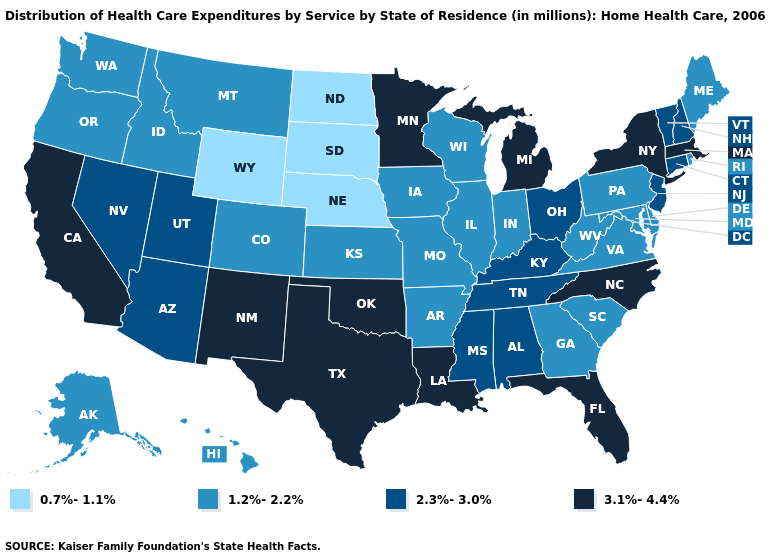Which states have the lowest value in the USA?
Concise answer only. Nebraska, North Dakota, South Dakota, Wyoming. What is the value of Delaware?
Answer briefly. 1.2%-2.2%. What is the highest value in states that border Connecticut?
Answer briefly. 3.1%-4.4%. Does the map have missing data?
Write a very short answer. No. Is the legend a continuous bar?
Concise answer only. No. Name the states that have a value in the range 3.1%-4.4%?
Give a very brief answer. California, Florida, Louisiana, Massachusetts, Michigan, Minnesota, New Mexico, New York, North Carolina, Oklahoma, Texas. Among the states that border Nevada , which have the lowest value?
Be succinct. Idaho, Oregon. Name the states that have a value in the range 3.1%-4.4%?
Give a very brief answer. California, Florida, Louisiana, Massachusetts, Michigan, Minnesota, New Mexico, New York, North Carolina, Oklahoma, Texas. What is the value of Wyoming?
Write a very short answer. 0.7%-1.1%. What is the value of Pennsylvania?
Keep it brief. 1.2%-2.2%. What is the highest value in the Northeast ?
Keep it brief. 3.1%-4.4%. Does Alaska have the highest value in the USA?
Keep it brief. No. Does North Dakota have the lowest value in the USA?
Short answer required. Yes. Does Maine have the lowest value in the Northeast?
Write a very short answer. Yes. 